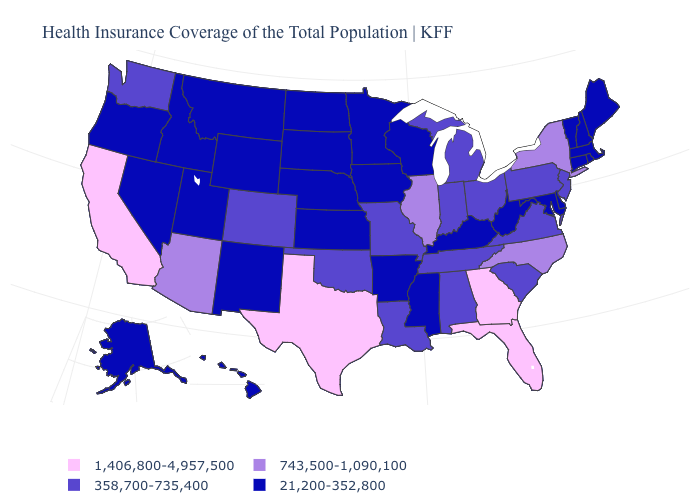What is the value of Ohio?
Concise answer only. 358,700-735,400. Name the states that have a value in the range 358,700-735,400?
Answer briefly. Alabama, Colorado, Indiana, Louisiana, Michigan, Missouri, New Jersey, Ohio, Oklahoma, Pennsylvania, South Carolina, Tennessee, Virginia, Washington. Among the states that border Oklahoma , does Colorado have the highest value?
Be succinct. No. What is the value of West Virginia?
Give a very brief answer. 21,200-352,800. Does Wyoming have the lowest value in the USA?
Write a very short answer. Yes. Name the states that have a value in the range 743,500-1,090,100?
Be succinct. Arizona, Illinois, New York, North Carolina. How many symbols are there in the legend?
Be succinct. 4. What is the value of Idaho?
Give a very brief answer. 21,200-352,800. Does Minnesota have the same value as Illinois?
Short answer required. No. Does Georgia have the highest value in the South?
Be succinct. Yes. Does the first symbol in the legend represent the smallest category?
Answer briefly. No. Does Georgia have the lowest value in the South?
Write a very short answer. No. What is the highest value in states that border California?
Give a very brief answer. 743,500-1,090,100. Does South Dakota have the lowest value in the MidWest?
Quick response, please. Yes. 